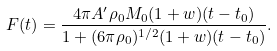Convert formula to latex. <formula><loc_0><loc_0><loc_500><loc_500>F ( t ) = \frac { 4 \pi A ^ { \prime } \rho _ { 0 } M _ { 0 } ( 1 + w ) ( t - t _ { 0 } ) } { 1 + ( 6 \pi \rho _ { 0 } ) ^ { 1 / 2 } ( 1 + w ) ( t - t _ { 0 } ) } .</formula> 